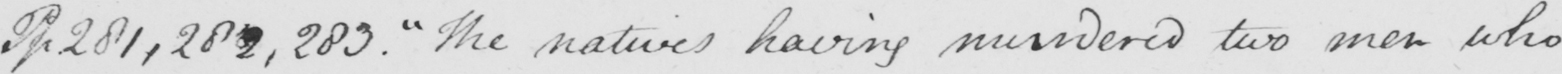Please provide the text content of this handwritten line. Pp 281,282,283 .  " The natives having murdered two men who 